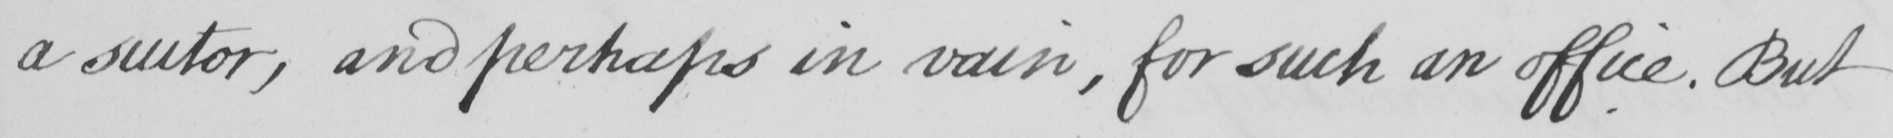What is written in this line of handwriting? a suitor , and perhaps in vain , for such an office . But 